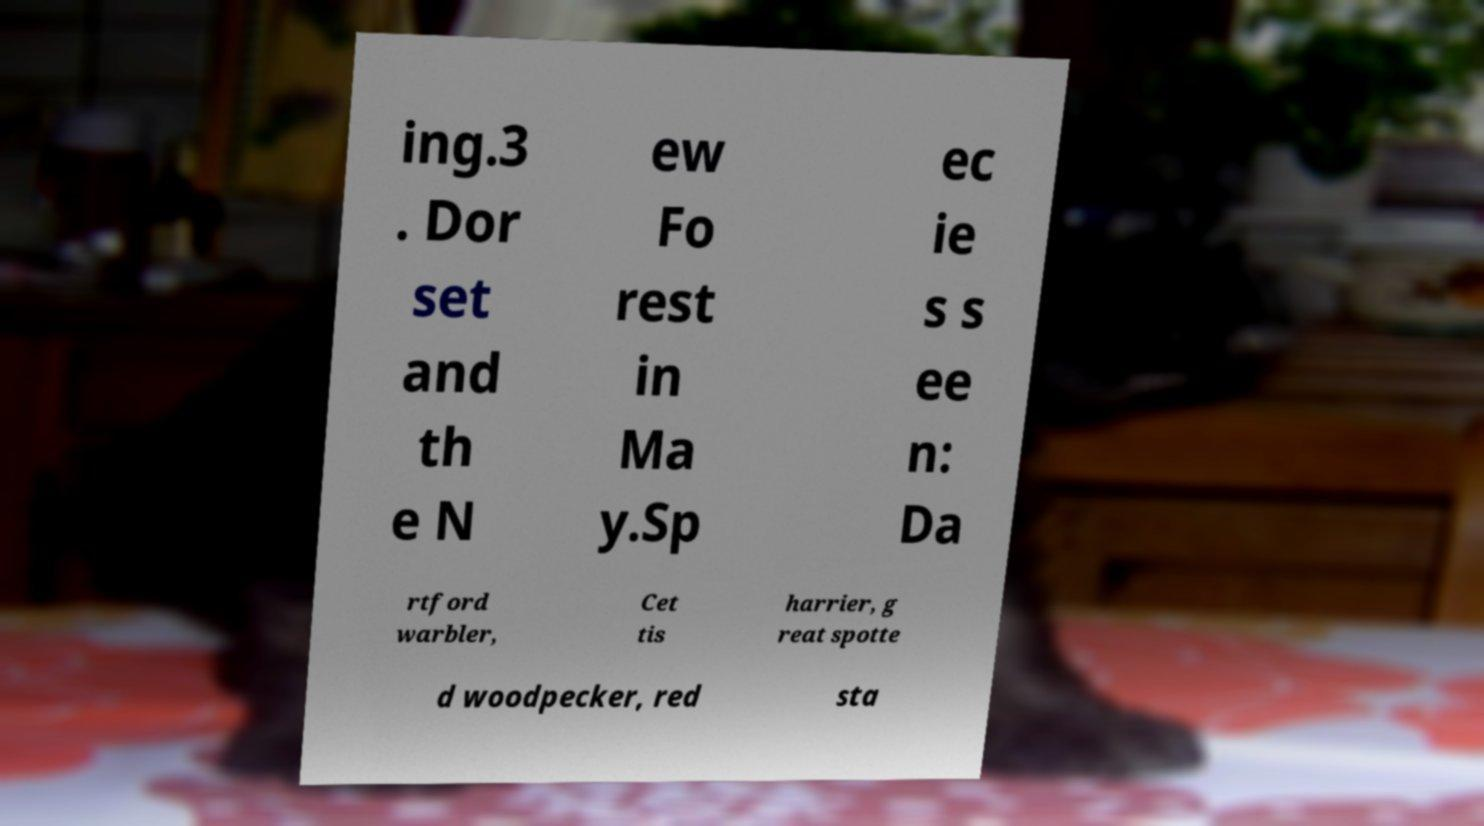Can you read and provide the text displayed in the image?This photo seems to have some interesting text. Can you extract and type it out for me? ing.3 . Dor set and th e N ew Fo rest in Ma y.Sp ec ie s s ee n: Da rtford warbler, Cet tis harrier, g reat spotte d woodpecker, red sta 